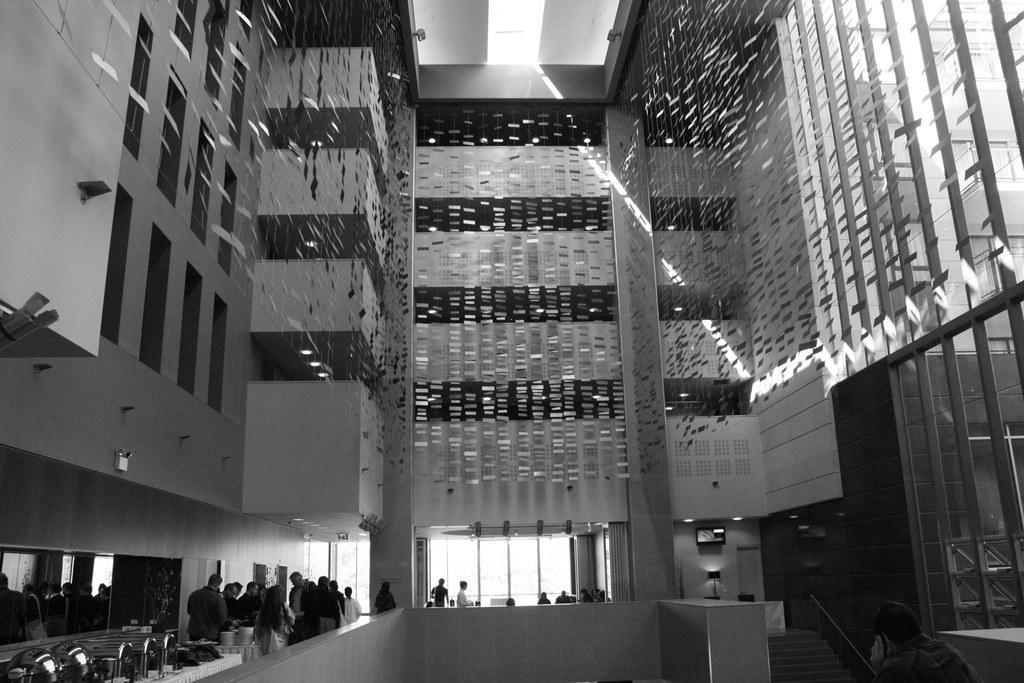Describe this image in one or two sentences. In this image there are some persons standing in the bottom of this image and there is a building in the background. 